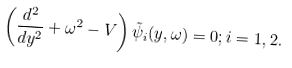<formula> <loc_0><loc_0><loc_500><loc_500>\left ( \frac { d ^ { 2 } } { d y ^ { 2 } } + \omega ^ { 2 } - V \right ) \tilde { \psi } _ { i } ( y , \omega ) = 0 ; i = 1 , 2 .</formula> 